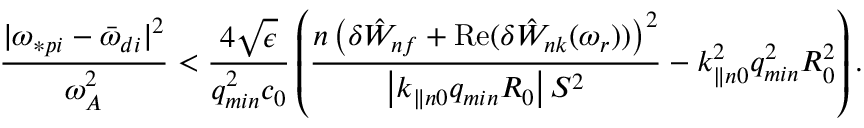Convert formula to latex. <formula><loc_0><loc_0><loc_500><loc_500>\frac { | \omega _ { \ast p i } - { \bar { \omega } } _ { d i } | ^ { 2 } } { \omega _ { A } ^ { 2 } } < \frac { 4 \sqrt { \epsilon } } { q _ { \min } ^ { 2 } c _ { 0 } } \left ( \frac { n \left ( \delta { \hat { W } } _ { n f } + R e ( { \delta { \hat { W } } _ { n k } ( \omega _ { r } ) ) } \right ) ^ { 2 } } { \left | k _ { \| n 0 } q _ { \min } R _ { 0 } \right | S ^ { 2 } } - k _ { \| n 0 } ^ { 2 } q _ { \min } ^ { 2 } R _ { 0 } ^ { 2 } \right ) .</formula> 